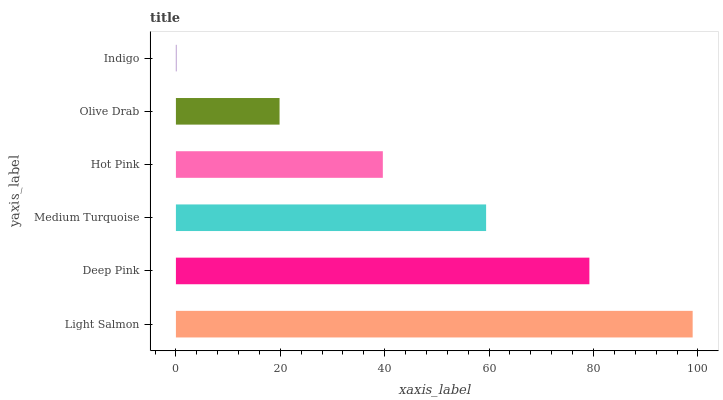Is Indigo the minimum?
Answer yes or no. Yes. Is Light Salmon the maximum?
Answer yes or no. Yes. Is Deep Pink the minimum?
Answer yes or no. No. Is Deep Pink the maximum?
Answer yes or no. No. Is Light Salmon greater than Deep Pink?
Answer yes or no. Yes. Is Deep Pink less than Light Salmon?
Answer yes or no. Yes. Is Deep Pink greater than Light Salmon?
Answer yes or no. No. Is Light Salmon less than Deep Pink?
Answer yes or no. No. Is Medium Turquoise the high median?
Answer yes or no. Yes. Is Hot Pink the low median?
Answer yes or no. Yes. Is Indigo the high median?
Answer yes or no. No. Is Indigo the low median?
Answer yes or no. No. 